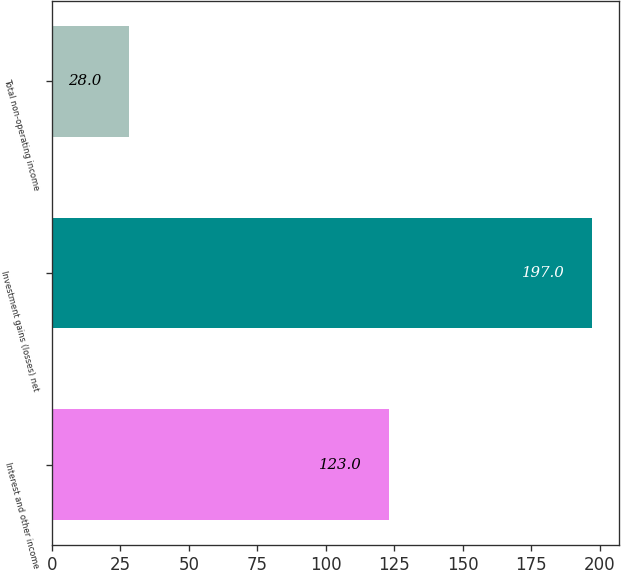<chart> <loc_0><loc_0><loc_500><loc_500><bar_chart><fcel>Interest and other income<fcel>Investment gains (losses) net<fcel>Total non-operating income<nl><fcel>123<fcel>197<fcel>28<nl></chart> 